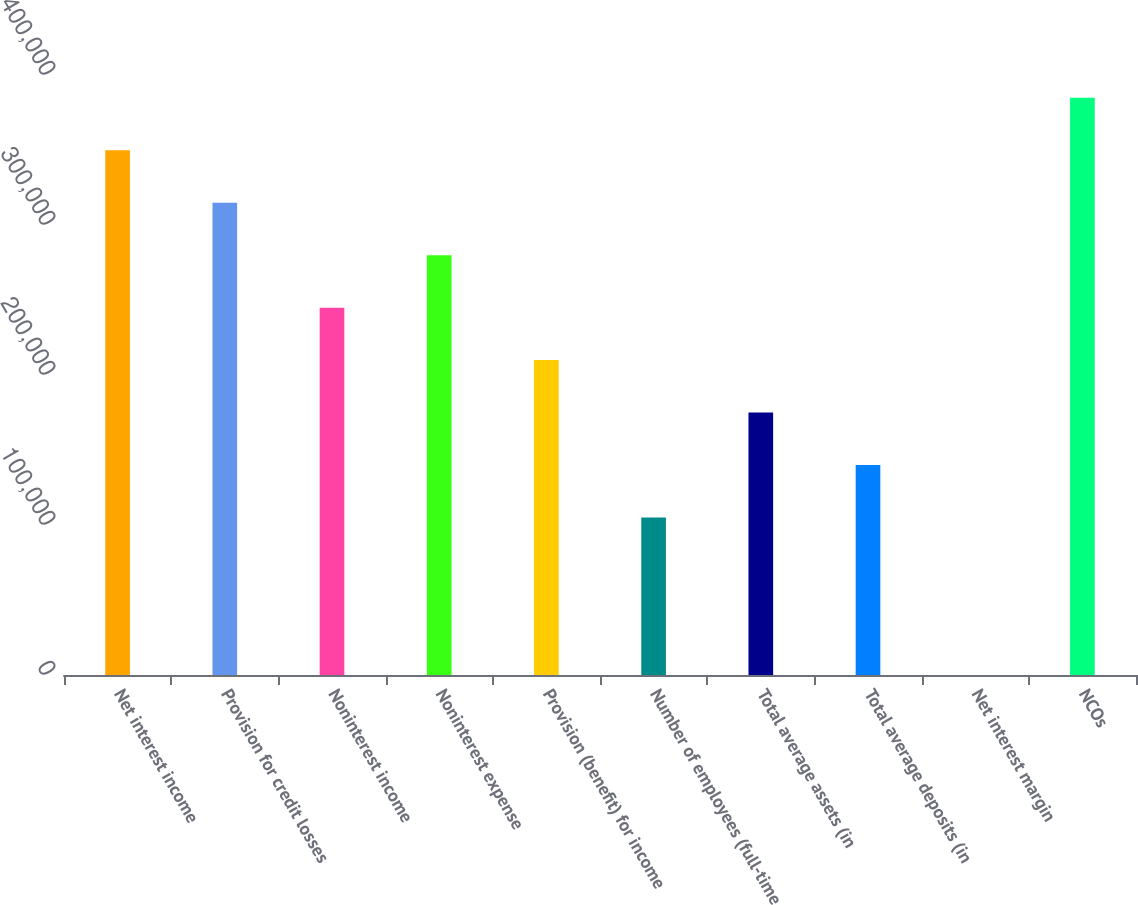Convert chart. <chart><loc_0><loc_0><loc_500><loc_500><bar_chart><fcel>Net interest income<fcel>Provision for credit losses<fcel>Noninterest income<fcel>Noninterest expense<fcel>Provision (benefit) for income<fcel>Number of employees (full-time<fcel>Total average assets (in<fcel>Total average deposits (in<fcel>Net interest margin<fcel>NCOs<nl><fcel>349869<fcel>314882<fcel>244909<fcel>279896<fcel>209922<fcel>104962<fcel>174936<fcel>139949<fcel>2.54<fcel>384856<nl></chart> 